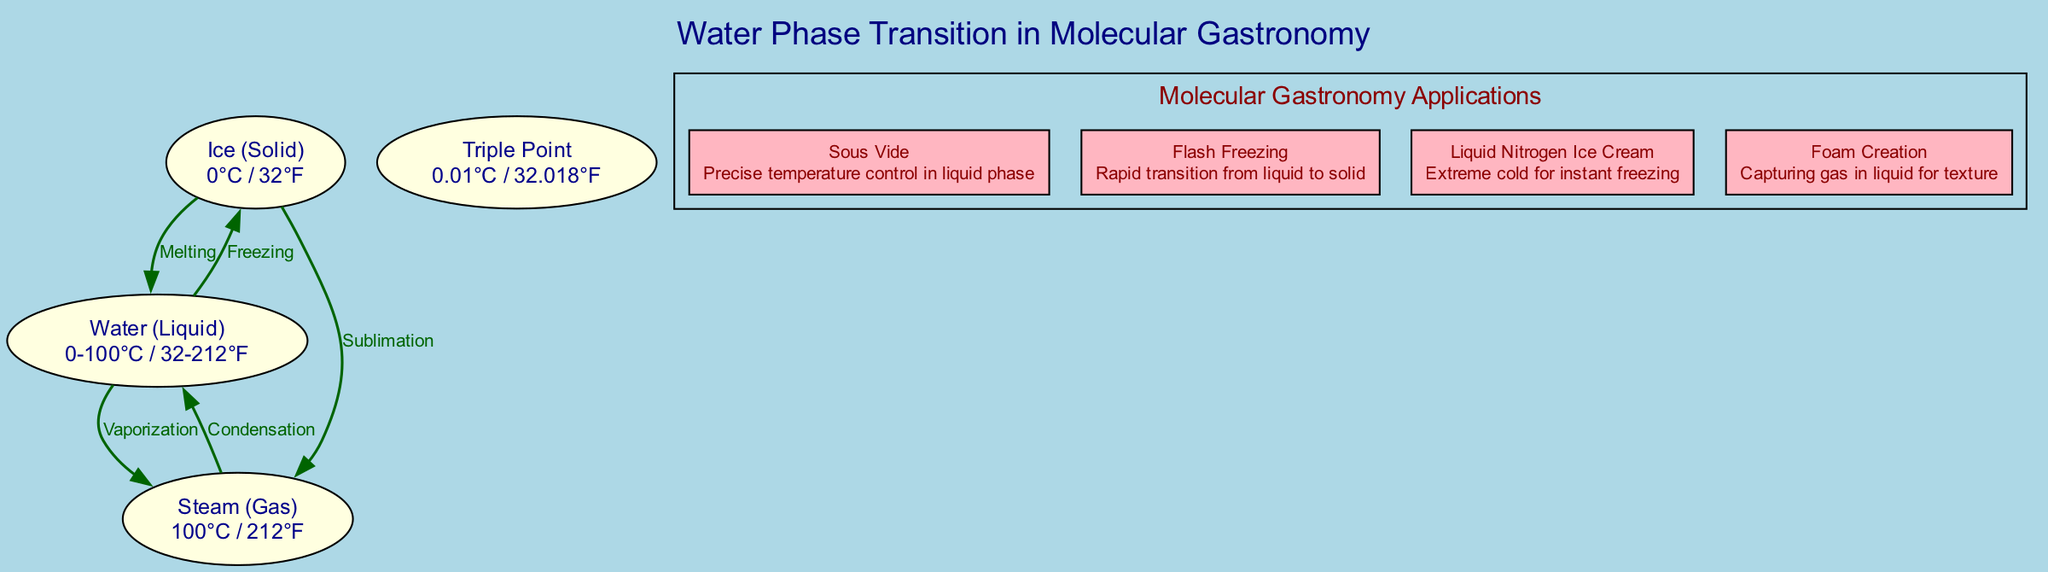What phase transformation occurs at 0 degrees Celsius? The diagram indicates that at 0 degrees Celsius, water transforms from solid to liquid through melting, which is clearly labeled in the edge connected to the solid node.
Answer: Melting What is the label for the gas phase of water? The diagram shows that the gas phase of water is labeled as "Steam (Gas)" with the appropriate details. This is found in the node representing the gas phase.
Answer: Steam (Gas) How many applications of molecular gastronomy are listed in the diagram? In the subgraph labeled 'Molecular Gastronomy Applications', there are four distinct applications listed, clearly displayed as separate nodes within this subgraph.
Answer: Four What is the temperature at which the triple point occurs? The triple point is defined in the diagram as occurring at 0.01 degrees Celsius, which is presented as part of the node details for the triple point node.
Answer: 0.01 degrees Celsius What technique describes rapid transition from liquid to solid? The diagram specifies that "Flash Freezing" is the technique that involves a rapid transition from the liquid phase to the solid phase, as stated under the applications section.
Answer: Flash Freezing Which phase transition leads to the creation of foam in cooking techniques? The creation of foam in cooking techniques relies on the "Capturing gas in liquid" principle, which is specifically mentioned in the description for the foam creation application. This indicates the relationship between gas and liquid phases in the diagram.
Answer: Foam Creation What is the relationship between liquid and gas phases in the diagram? The diagram defines the relationship between the liquid and gas phases as "Vaporization", which is represented by the edge connecting these two nodes, illustrating the phase transition process.
Answer: Vaporization Which phase of water occurs at temperatures below zero degrees Celsius? The diagram indicates that at temperatures below zero degrees Celsius, water exists in the solid phase, specifically represented as ice in the node for the solid phase.
Answer: Ice (Solid) 